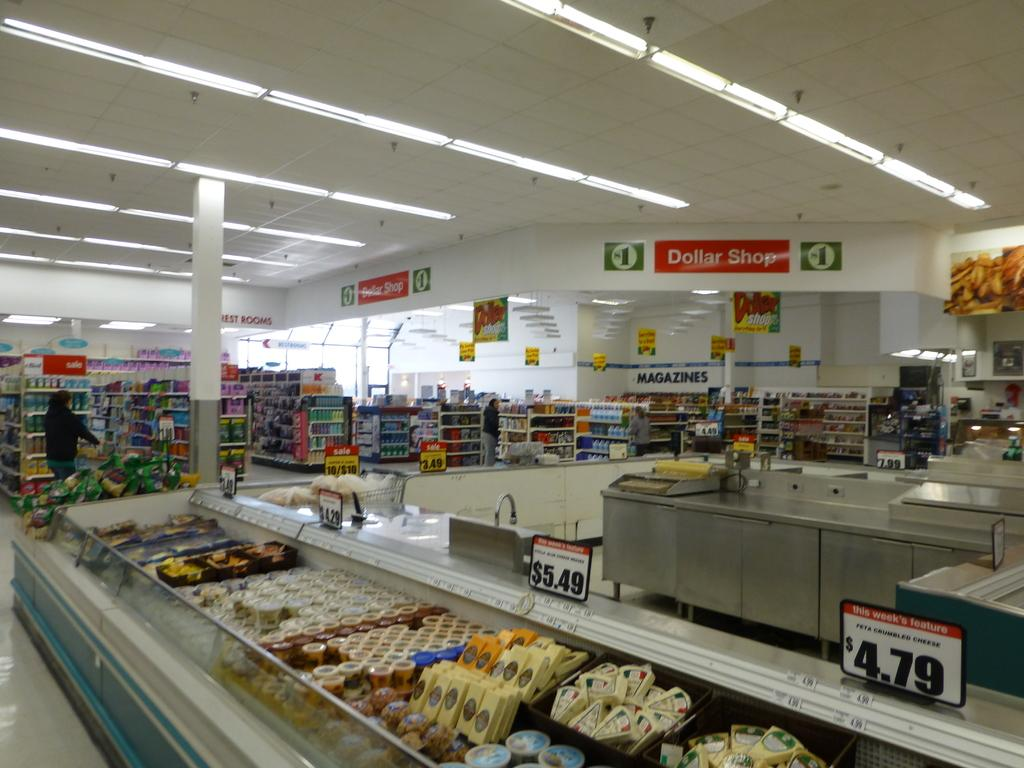<image>
Summarize the visual content of the image. An assortment of cheeses are for sale for between four and six dollars at Dollar Shop. 